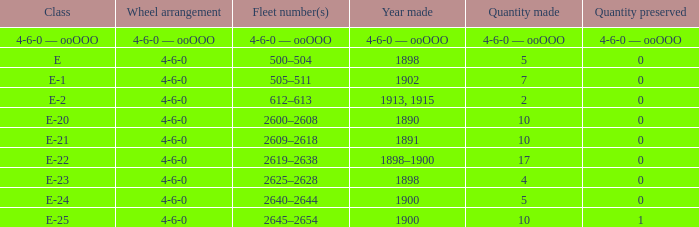What is the wheel arrangement with 1 quantity preserved? 4-6-0. 